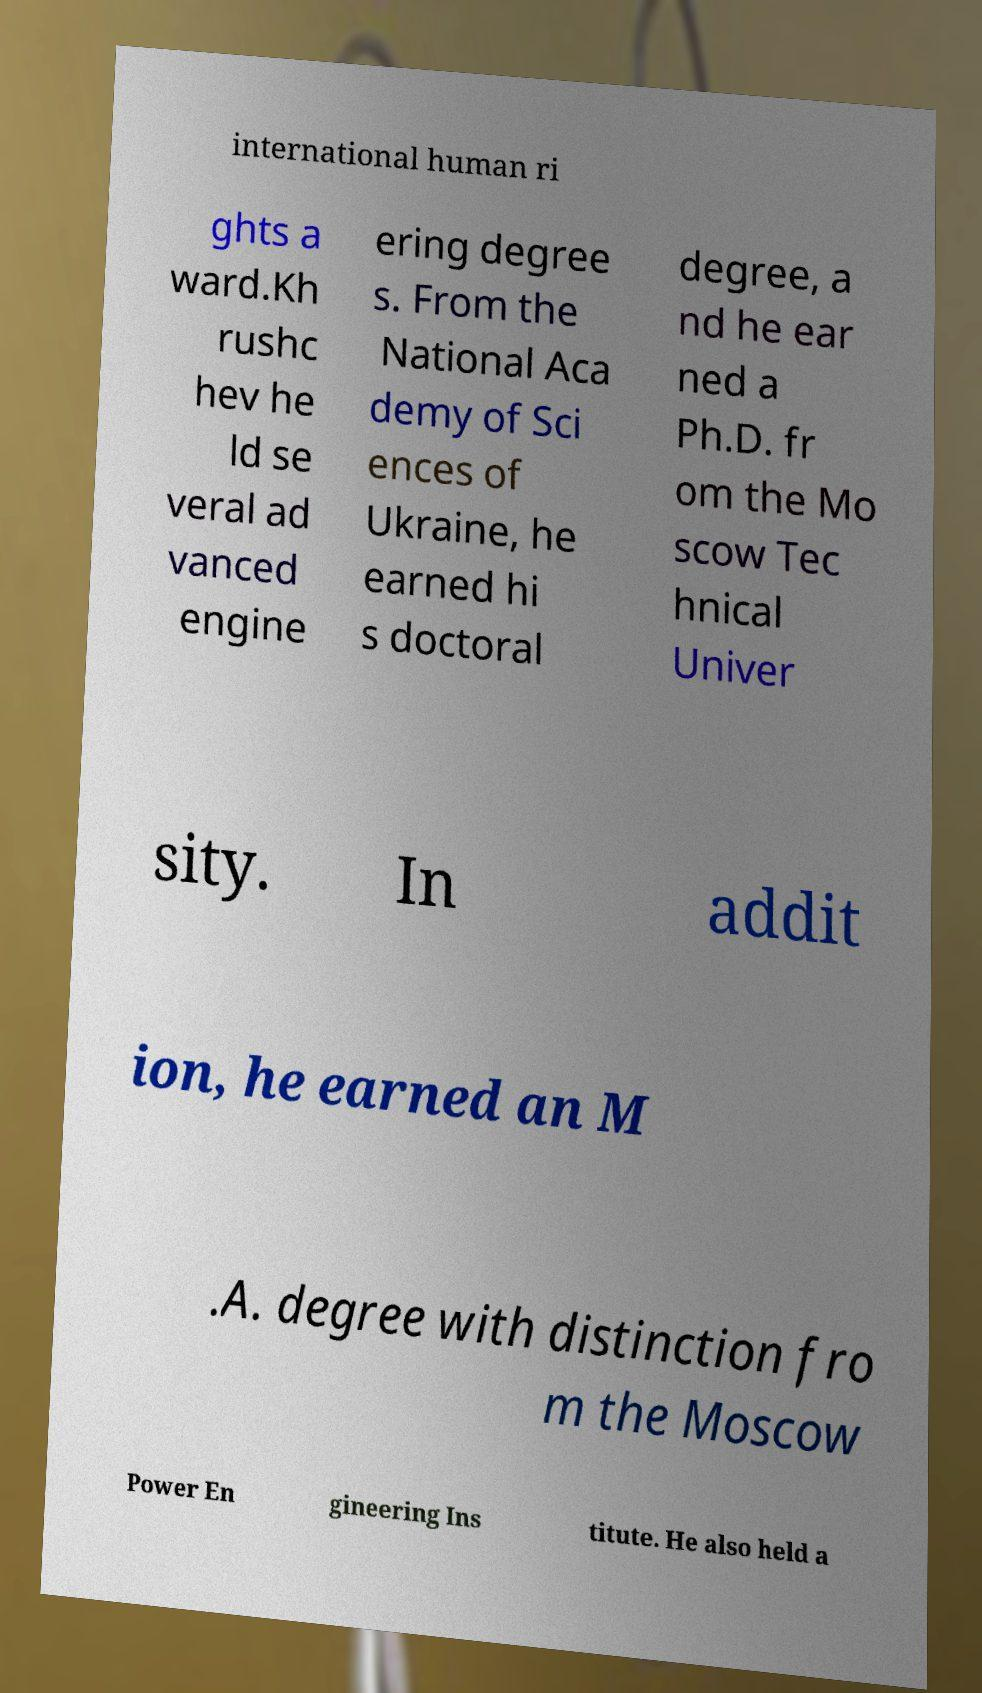I need the written content from this picture converted into text. Can you do that? international human ri ghts a ward.Kh rushc hev he ld se veral ad vanced engine ering degree s. From the National Aca demy of Sci ences of Ukraine, he earned hi s doctoral degree, a nd he ear ned a Ph.D. fr om the Mo scow Tec hnical Univer sity. In addit ion, he earned an M .A. degree with distinction fro m the Moscow Power En gineering Ins titute. He also held a 